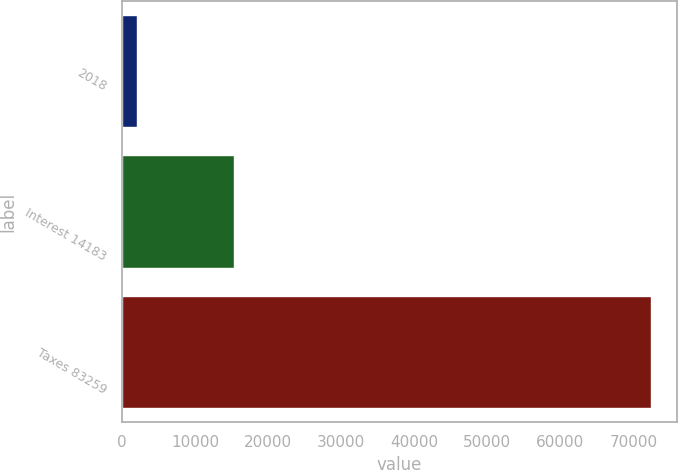Convert chart to OTSL. <chart><loc_0><loc_0><loc_500><loc_500><bar_chart><fcel>2018<fcel>Interest 14183<fcel>Taxes 83259<nl><fcel>2017<fcel>15394<fcel>72340<nl></chart> 